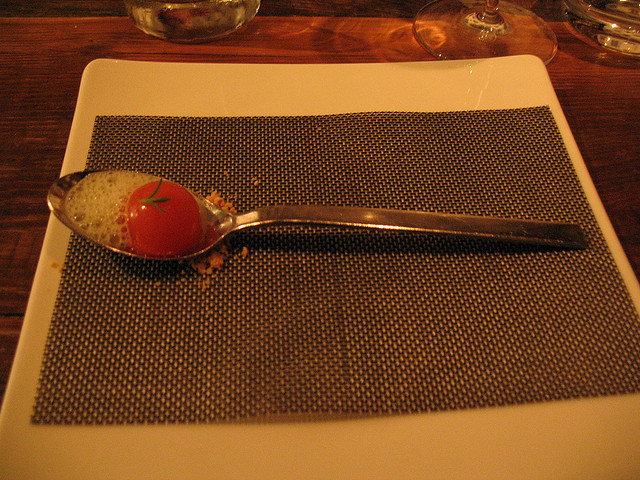What cuisine does this presentation resemble? The presentation harbors a modernist culinary approach, often associated with the molecular gastronomy cuisine. This style focuses on the art and science of cooking, presenting familiar flavors in visually unexpected forms. Is molecular gastronomy popular? Molecular gastronomy gained significant popularity in the early 2000s with chefs like Ferran Adrià leading the movement. While the initial hype has normalized, it remains a respected and innovative culinary approach that many fine dining establishments and curious chefs continue to explore. 